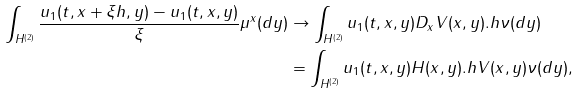Convert formula to latex. <formula><loc_0><loc_0><loc_500><loc_500>\int _ { H ^ { ( 2 ) } } \frac { u _ { 1 } ( t , x + \xi h , y ) - u _ { 1 } ( t , x , y ) } { \xi } \mu ^ { x } ( d y ) & \rightarrow \int _ { H ^ { ( 2 ) } } u _ { 1 } ( t , x , y ) D _ { x } V ( x , y ) . h \nu ( d y ) \\ & = \int _ { H ^ { ( 2 ) } } u _ { 1 } ( t , x , y ) H ( x , y ) . h V ( x , y ) \nu ( d y ) ,</formula> 